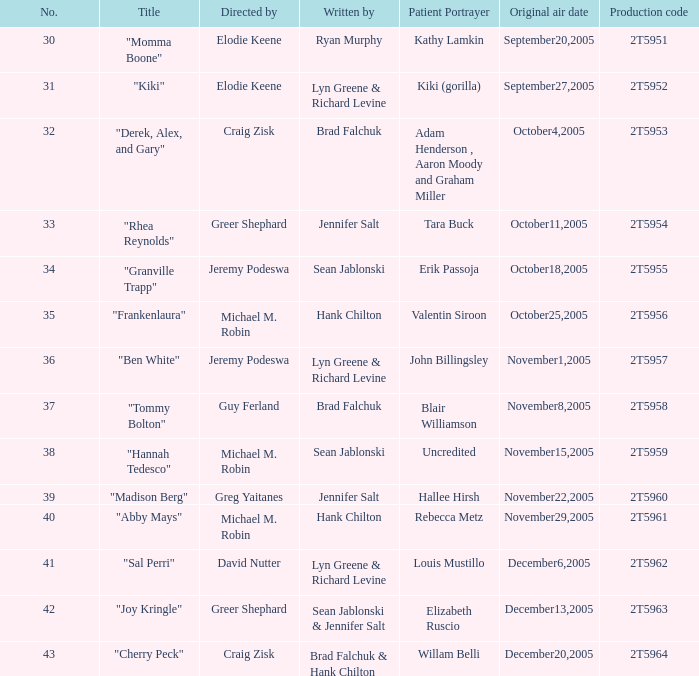Who are the authors of the episode called "ben white"? Lyn Greene & Richard Levine. 